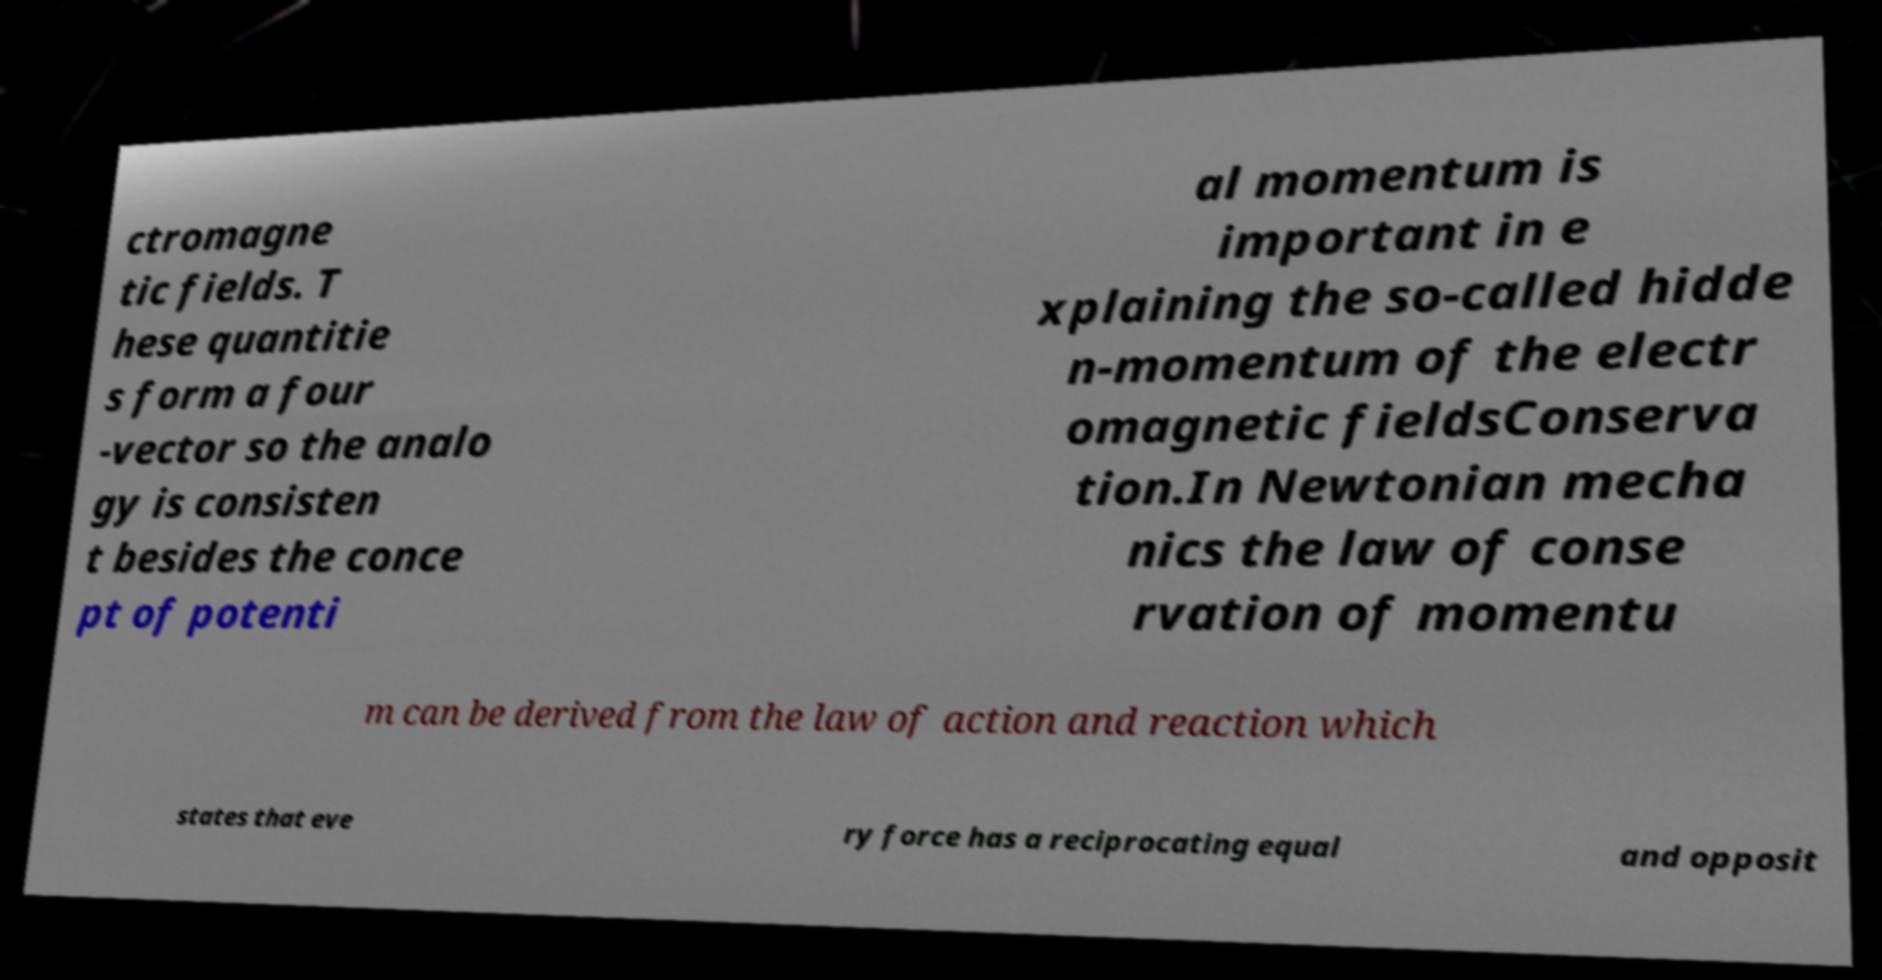Could you assist in decoding the text presented in this image and type it out clearly? ctromagne tic fields. T hese quantitie s form a four -vector so the analo gy is consisten t besides the conce pt of potenti al momentum is important in e xplaining the so-called hidde n-momentum of the electr omagnetic fieldsConserva tion.In Newtonian mecha nics the law of conse rvation of momentu m can be derived from the law of action and reaction which states that eve ry force has a reciprocating equal and opposit 